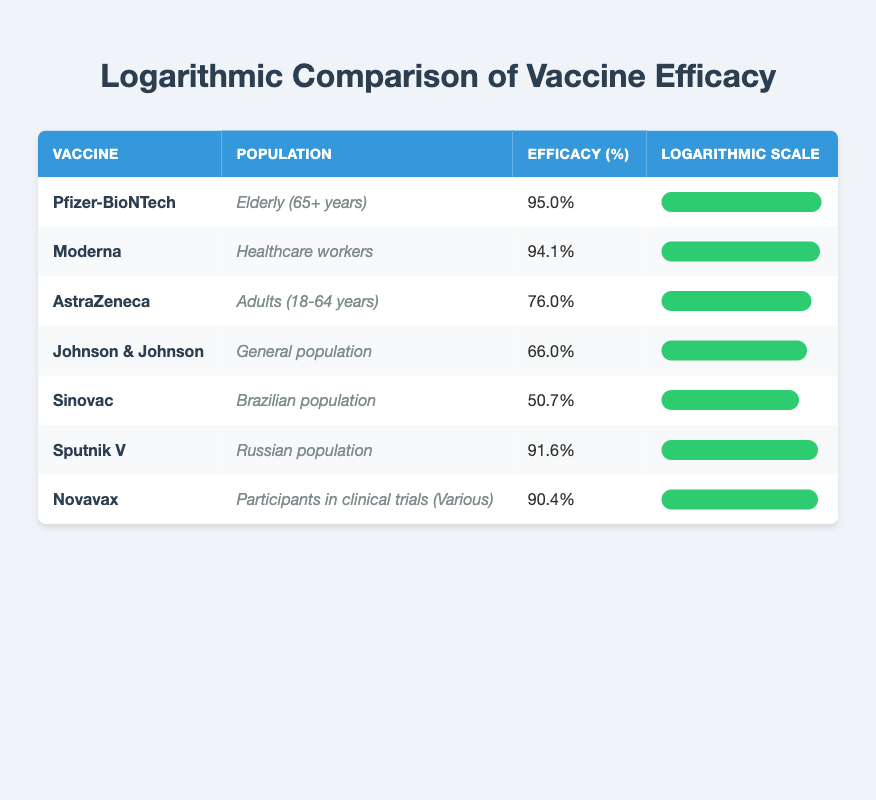What is the efficacy percentage of the Pfizer-BioNTech vaccine? The efficacy percentage for the Pfizer-BioNTech vaccine is listed directly in the table under "Efficacy (%)" for that row, which is 95.0%.
Answer: 95.0% Which vaccine has the lowest efficacy percentage? By reviewing the "Efficacy (%)" column in the table, the lowest percentage is for Sinovac at 50.7%.
Answer: Sinovac Is the efficacy of the AstraZeneca vaccine higher than that of Johnson & Johnson? Comparing the efficacy percentages, AstraZeneca has an efficacy of 76.0% and Johnson & Johnson has 66.0%. Since 76.0% is greater than 66.0%, the answer is yes.
Answer: Yes What is the average efficacy percentage of the five vaccines with the lowest efficacy values? The five lowest efficacy values are: AstraZeneca (76.0%), Johnson & Johnson (66.0%), Sinovac (50.7%), Sputnik V (91.6%), and Novavax (90.4%). First, we sum these values: 76.0 + 66.0 + 50.7 + 91.6 + 90.4 = 374.7. Then, we divide by 5 to find the average: 374.7 / 5 = 74.94.
Answer: 74.94 Does the table indicate that the Moderna vaccine is more effective than Novavax? Moderna has an efficacy of 94.1%, while Novavax has an efficacy of 90.4%. Since 94.1% is greater than 90.4%, the statement is true.
Answer: Yes Which vaccine is aimed at the elderly population and how effective is it? The vaccine aimed at the elderly population (65+ years) is Pfizer-BioNTech, with an efficacy percentage of 95.0%.
Answer: Pfizer-BioNTech, 95.0% How many vaccines have an efficacy percentage above 90%? According to the table, the vaccines with efficacy percentages above 90% are Pfizer-BioNTech (95.0%), Moderna (94.1%), Sputnik V (91.6%), and Novavax (90.4%). Therefore, there are 4 vaccines above that threshold.
Answer: 4 What is the difference in efficacy between the AstraZeneca and Sinovac vaccines? AstraZeneca has an efficacy of 76.0% and Sinovac has 50.7%. The difference is calculated as 76.0 - 50.7 = 25.3%.
Answer: 25.3% Which population received the vaccine with the efficacy closest to 90%? Looking at the table, Novavax has an efficacy of 90.4%, which is closest to 90%. It is administered to participants in clinical trials, indicating that this group received the vaccine.
Answer: Participants in clinical trials (Various) 